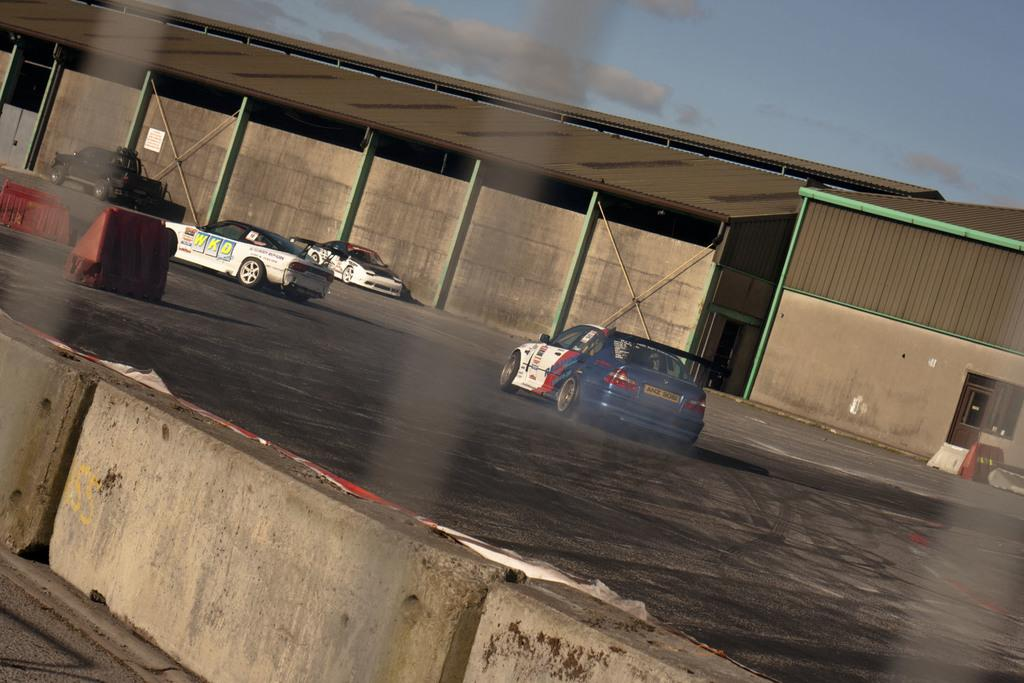What can be seen in the image? There are vehicles in the image. What is located in the background of the image? There is a shed in the background, which is brown in color. What separates the vehicles from the rest of the scene? There is a concrete divider in front of the vehicles. What can be seen in the sky in the image? The sky is visible in the background, and it is blue and white in color. What type of chair is being used to perform the action in the image? There is no chair or action being performed in the image; it features vehicles, a shed, a concrete divider, and a blue and white sky. 